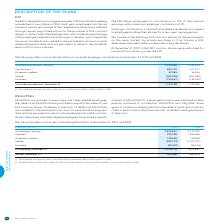According to Bce's financial document, What is the weighted average fair value of the RSUs/PSUs granted in 2019? According to the financial document, $58. The relevant text states: "ed average fair value of the RSUs/PSUs granted was $58 in 2019 and $57 in 2018...." Also, Who are the RSUs/PSUs granted to? executives and other eligible employees. The document states: "RSUs/PSUs are granted to executives and other eligible employees. The value of an RSU/PSU at the grant date is equal to the value of one BCE common sh..." Also, What conditions determine whether executives and other eligible employees are granted RSUs/PSUs? The document contains multiple relevant values: position, level of contribution, in certain cases, if performance objectives are met. From the document: "en performance period based on their position and level of contribution. RSUs/PSUs vest fully after three years of continuous employment from the date..." Additionally, In which year is the amount of dividends credited larger? According to the financial document, 2019. The relevant text states: "NUMBER OF RSUs/PSUs 2019 2018..." Also, can you calculate: What is the change in the weighted average fair value of the RSUs/PSUs granted? Based on the calculation: $58-$57, the result is 1. This is based on the information: "Dividends credited 57,083 56,926 Granted (1) 975,348 1,006,586..." The key data points involved are: 57, 58. Also, can you calculate: What is the average vested amount in 2018 and 2019? To answer this question, I need to perform calculations using the financial data. The calculation is: (904,266+880,903)/2, which equals 892584.5. This is based on the information: "Vested, December 31 (2) 904,266 880,903 Vested, December 31 (2) 904,266 880,903..." The key data points involved are: 880,903, 904,266. 